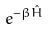Convert formula to latex. <formula><loc_0><loc_0><loc_500><loc_500>e ^ { - \beta \hat { H } }</formula> 